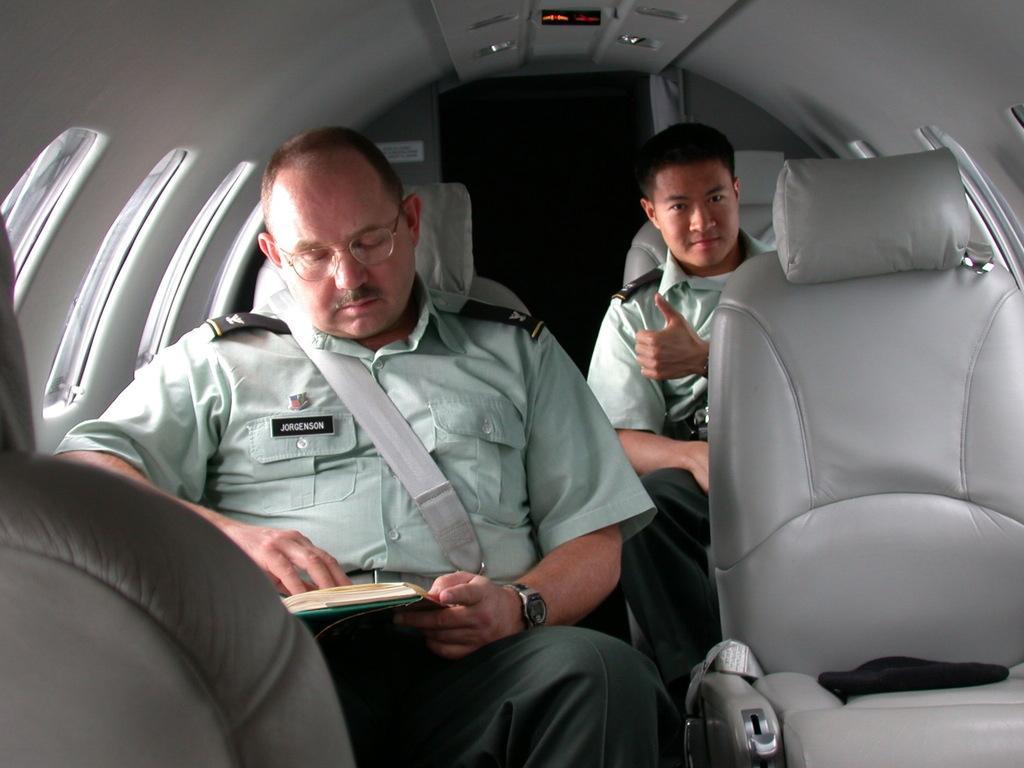In one or two sentences, can you explain what this image depicts? This picture is clicked inside the vehicle. On the right we can see the seat of a vehicle. On the left we can see the two persons wearing uniforms and sitting on the seats and we can see the book. In the background we can see the roof of the vehicle and the lights and we can see the windows. 